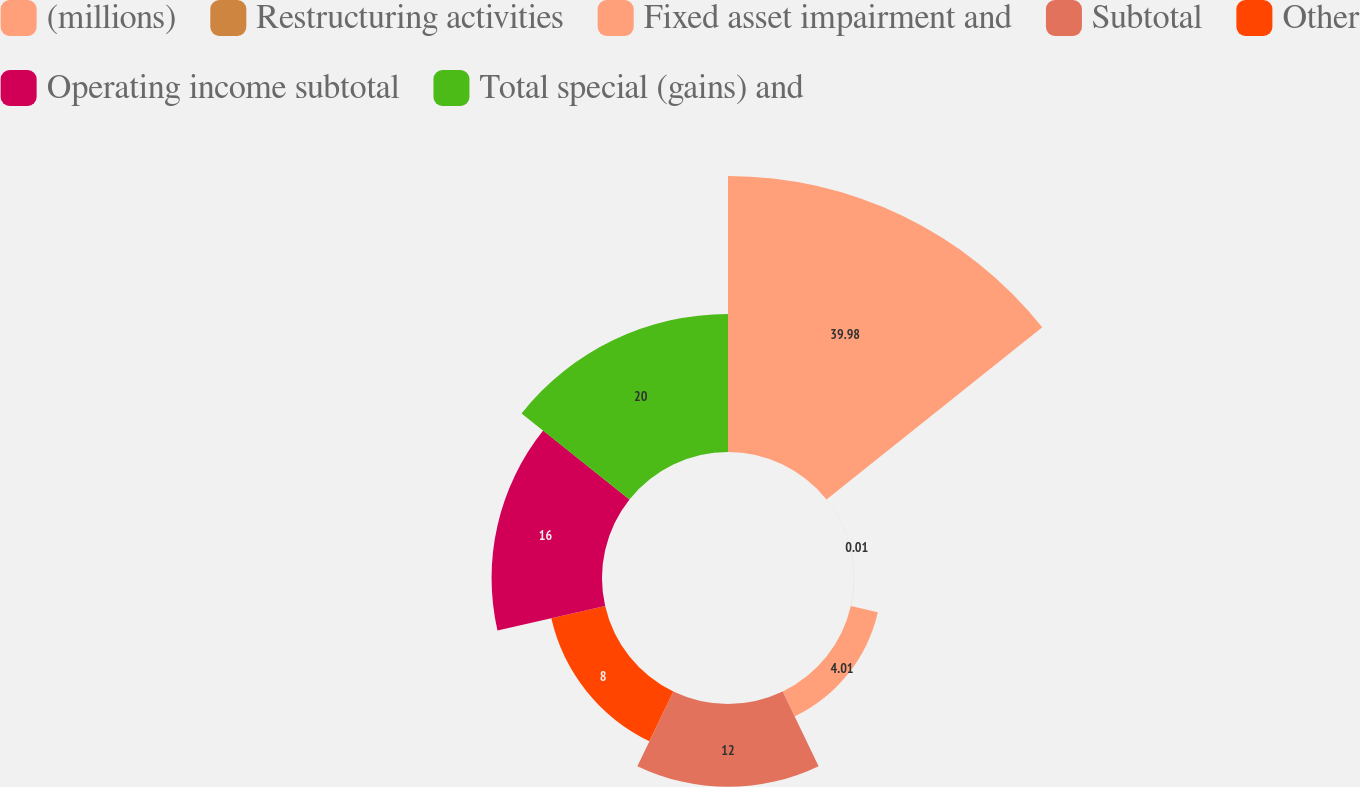Convert chart. <chart><loc_0><loc_0><loc_500><loc_500><pie_chart><fcel>(millions)<fcel>Restructuring activities<fcel>Fixed asset impairment and<fcel>Subtotal<fcel>Other<fcel>Operating income subtotal<fcel>Total special (gains) and<nl><fcel>39.99%<fcel>0.01%<fcel>4.01%<fcel>12.0%<fcel>8.0%<fcel>16.0%<fcel>20.0%<nl></chart> 